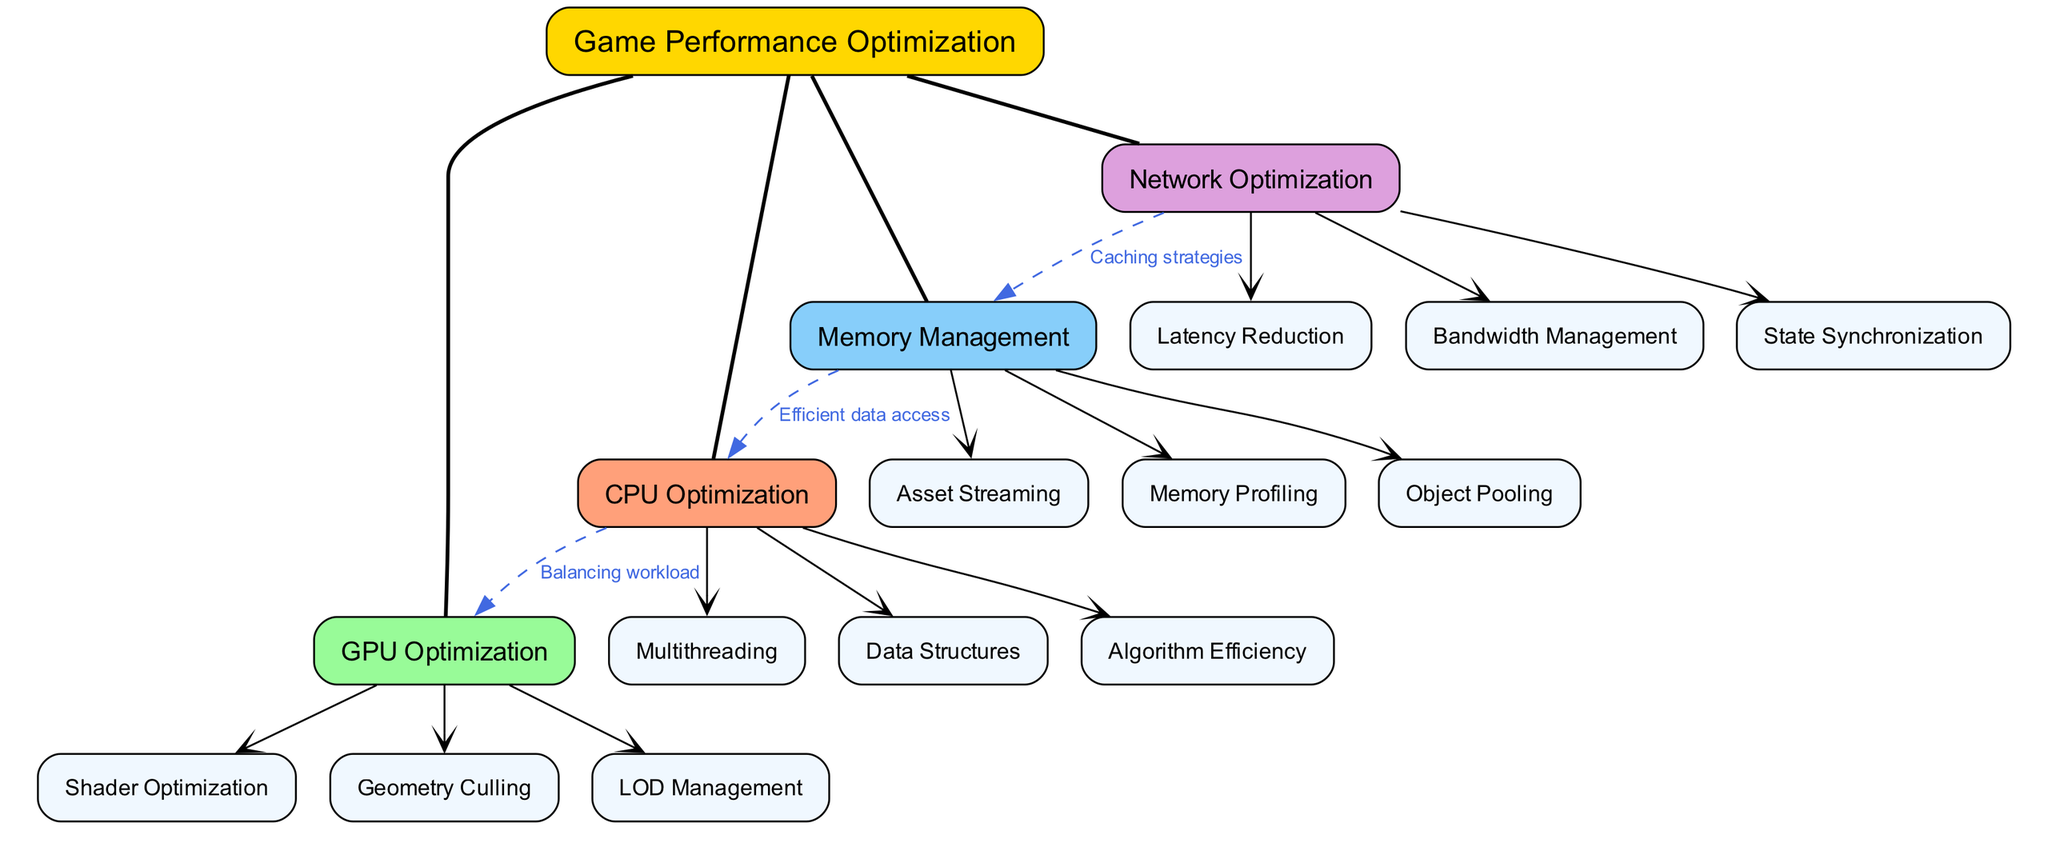What is the central node of the diagram? The central node is explicitly labeled as "Game Performance Optimization" in the diagram. It serves as the primary focus of the concept map.
Answer: Game Performance Optimization How many main branches are connected to the central node? There are four main branches listed under the central node: CPU Optimization, GPU Optimization, Memory Management, and Network Optimization. This can be counted directly from the diagram.
Answer: 4 What technique is labeled under CPU Optimization? One of the sub-nodes under CPU Optimization is "Multithreading", which is a performance optimization technique dealing with parallel processing. This direct information can be found in the corresponding section of the diagram.
Answer: Multithreading Which sub-node is connected to Network Optimization? The sub-node directly connected to Network Optimization is "Latency Reduction" as it is the first listed under this branch. The connection can be traced visually in the diagram.
Answer: Latency Reduction What is the relationship between Memory Management and CPU Optimization? The diagram indicates that Memory Management impacts CPU Optimization through "Efficient data access", which is a labeled connection between the respective branches. This relationship illustrates the dependency between them.
Answer: Efficient data access Which optimization technique is mentioned twice in the connections section? While examining the connections, the optimized technique "Memory Management" interacts with both "CPU Optimization" and "Network Optimization", indicating its importance in overall game performance, based on the connections presented.
Answer: Memory Management What style is used for the edges connecting the sub-nodes to main branches? The edges that connect sub-nodes to their corresponding main branches are shown with an arrowhead styled as "vee" in the diagram, representing a directional flow from branch to sub-nodes.
Answer: Vee How does GPU Optimization relate to CPU Optimization? The diagram indicates that the two branches are connected by the label "Balancing workload", signifying a relationship that emphasizes the balance of processing workload between CPU and GPU efforts for optimization.
Answer: Balancing workload Which sub-node appears first under GPU Optimization? The first sub-node listed under GPU Optimization is "Shader Optimization", indicating it as a primary focus area for optimizing graphics processing. This can be seen in the arrangement of sub-nodes originating from that branch.
Answer: Shader Optimization 